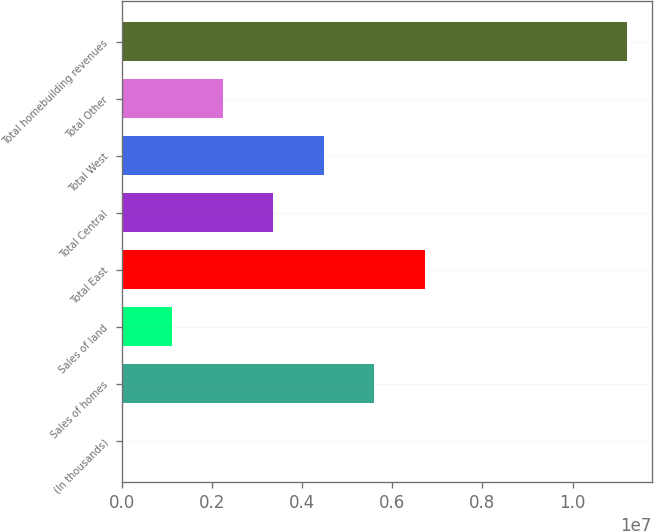Convert chart to OTSL. <chart><loc_0><loc_0><loc_500><loc_500><bar_chart><fcel>(In thousands)<fcel>Sales of homes<fcel>Sales of land<fcel>Total East<fcel>Total Central<fcel>Total West<fcel>Total Other<fcel>Total homebuilding revenues<nl><fcel>2017<fcel>5.60113e+06<fcel>1.12184e+06<fcel>6.72095e+06<fcel>3.36148e+06<fcel>4.48131e+06<fcel>2.24166e+06<fcel>1.12002e+07<nl></chart> 